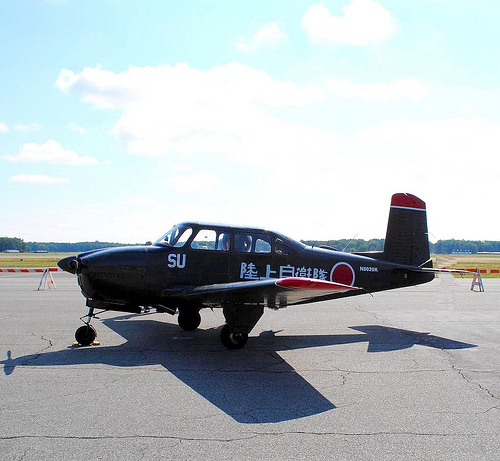Please provide a short description for this region: [0.4, 0.5, 0.46, 0.54]. This region highlights one of the plane's windows, offering a glimpse into the passenger cabin or outward views from within the plane. 